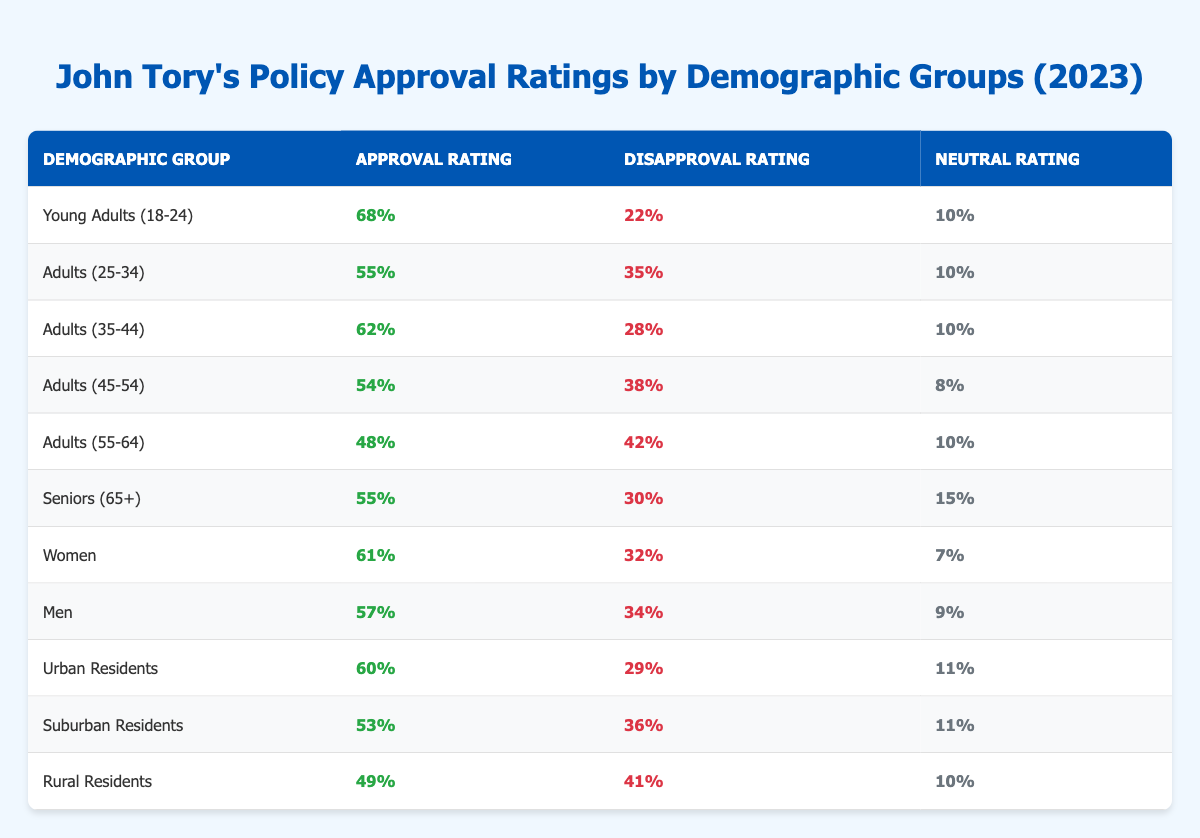What is the approval rating for Young Adults (18-24)? The approval rating for Young Adults (18-24) is directly provided in the table as 68%.
Answer: 68% Which demographic group has the highest disapproval rating? To find this, compare the disapproval ratings of all groups. Young Adults (22%), Adults (25-34) (35%), Adults (35-44) (28%), Adults (45-54) (38%), Adults (55-64) (42%), Seniors (65+) (30%), Women (32%), Men (34%), Urban Residents (29%), Suburban Residents (36%), and Rural Residents (41%). The highest is 42% for Adults (55-64).
Answer: Adults (55-64) What is the average approval rating across all demographic groups? To calculate the average, sum all the approval ratings (68 + 55 + 62 + 54 + 48 + 55 + 61 + 57 + 60 + 53 + 49 =  606), and divide by the number of groups (11): 606 / 11 ≈ 55.09.
Answer: 55.09 Is the neutral rating for Seniors (65+) greater than the neutral rating for Young Adults (18-24)? The neutral rating for Seniors (65+) is 15%, and for Young Adults (18-24) it is 10%. Since 15% > 10%, the statement is true.
Answer: Yes What is the difference in approval ratings between Women and Rural Residents? The approval rating for Women is 61%, and for Rural Residents, it is 49%. The difference is 61% - 49% = 12%.
Answer: 12% Which demographic groups have an approval rating below 55%? Looking at the table, the groups with approval ratings below 55% are Adults (55-64) (48%) and Rural Residents (49%). These two groups meet the criteria.
Answer: Adults (55-64) and Rural Residents How many demographic groups have an approval rating of 60% or higher? The groups with at least 60% approval are Young Adults (68%), Adults (35-44) (62%), Women (61%), and Urban Residents (60%)—a total of 4 groups.
Answer: 4 What is the relationship between age and approval rating based on the table? Analyzing the table, younger age groups tend to have higher approval ratings (68% for Young Adults) while older groups (55-64 years and Rural Residents) show lower approval ratings (48% and 49% respectively). Thus, generally, younger demographics seem more approving.
Answer: Younger groups trend higher in approval ratings Which gender demographic has a higher disapproval rating? The disapproval rating for Women is 32%, while for Men it is 34%. Since 34% > 32%, Men have a higher disapproval rating.
Answer: Men If you combine the approval ratings of both Young Adults (18-24) and Seniors (65+), what is the total? The approval ratings for Young Adults is 68% and for Seniors is 55%. Summing these gives 68% + 55% = 123%.
Answer: 123% 